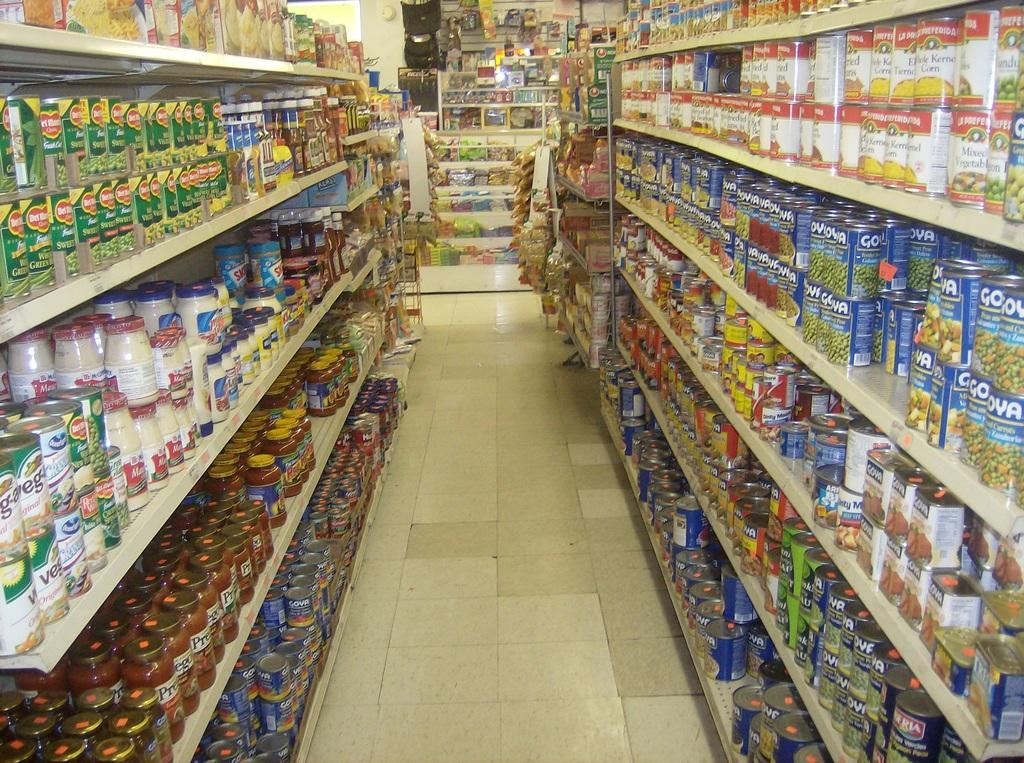What type of structure is present in the image? There are racks in the image. What is stored on the racks? There are bottles and food items in the image. Where are the racks and their contents located? The objects are on the floor. What type of veil can be seen covering the engine in the image? There is no veil or engine present in the image; it features racks with bottles and food items on the floor. 